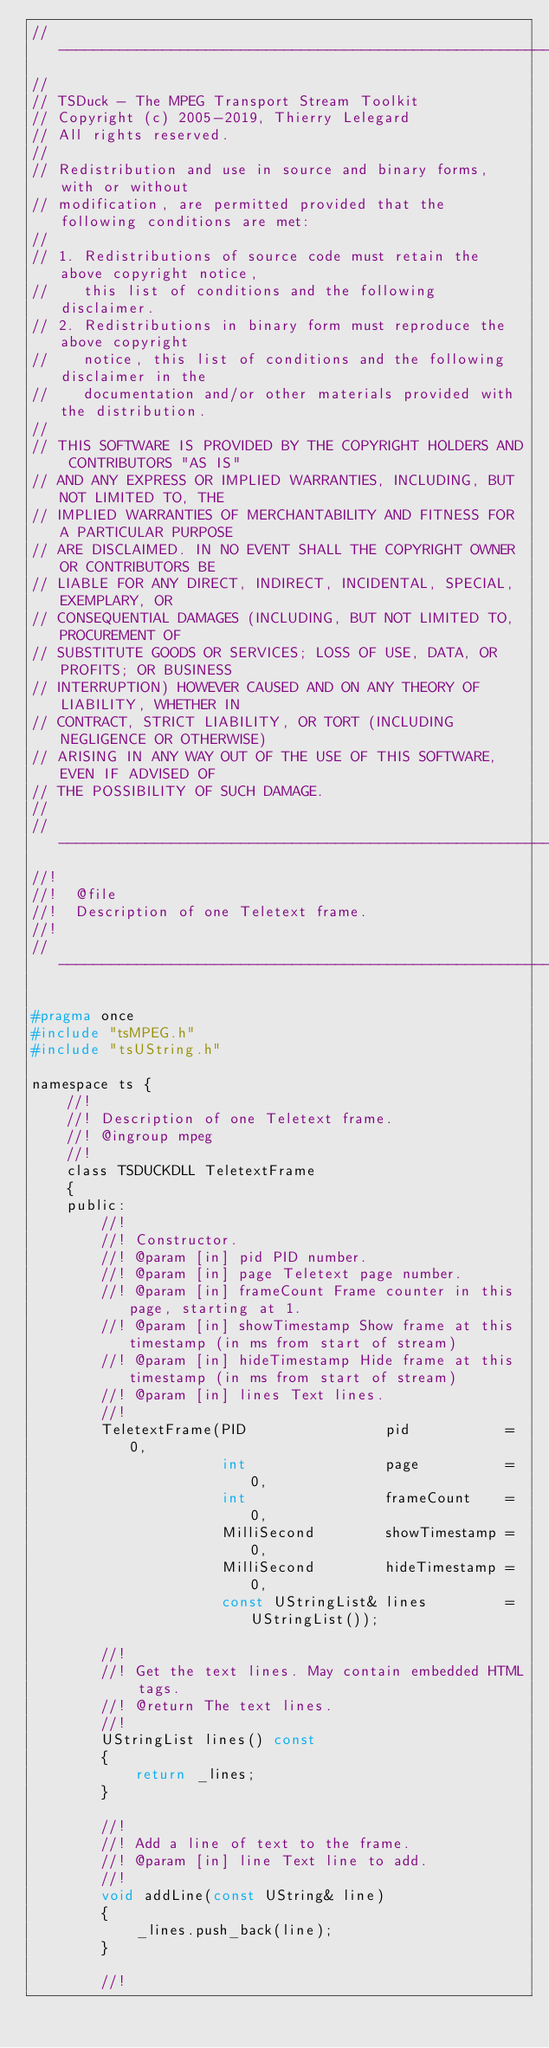<code> <loc_0><loc_0><loc_500><loc_500><_C_>//----------------------------------------------------------------------------
//
// TSDuck - The MPEG Transport Stream Toolkit
// Copyright (c) 2005-2019, Thierry Lelegard
// All rights reserved.
//
// Redistribution and use in source and binary forms, with or without
// modification, are permitted provided that the following conditions are met:
//
// 1. Redistributions of source code must retain the above copyright notice,
//    this list of conditions and the following disclaimer.
// 2. Redistributions in binary form must reproduce the above copyright
//    notice, this list of conditions and the following disclaimer in the
//    documentation and/or other materials provided with the distribution.
//
// THIS SOFTWARE IS PROVIDED BY THE COPYRIGHT HOLDERS AND CONTRIBUTORS "AS IS"
// AND ANY EXPRESS OR IMPLIED WARRANTIES, INCLUDING, BUT NOT LIMITED TO, THE
// IMPLIED WARRANTIES OF MERCHANTABILITY AND FITNESS FOR A PARTICULAR PURPOSE
// ARE DISCLAIMED. IN NO EVENT SHALL THE COPYRIGHT OWNER OR CONTRIBUTORS BE
// LIABLE FOR ANY DIRECT, INDIRECT, INCIDENTAL, SPECIAL, EXEMPLARY, OR
// CONSEQUENTIAL DAMAGES (INCLUDING, BUT NOT LIMITED TO, PROCUREMENT OF
// SUBSTITUTE GOODS OR SERVICES; LOSS OF USE, DATA, OR PROFITS; OR BUSINESS
// INTERRUPTION) HOWEVER CAUSED AND ON ANY THEORY OF LIABILITY, WHETHER IN
// CONTRACT, STRICT LIABILITY, OR TORT (INCLUDING NEGLIGENCE OR OTHERWISE)
// ARISING IN ANY WAY OUT OF THE USE OF THIS SOFTWARE, EVEN IF ADVISED OF
// THE POSSIBILITY OF SUCH DAMAGE.
//
//----------------------------------------------------------------------------
//!
//!  @file
//!  Description of one Teletext frame.
//!
//----------------------------------------------------------------------------

#pragma once
#include "tsMPEG.h"
#include "tsUString.h"

namespace ts {
    //!
    //! Description of one Teletext frame.
    //! @ingroup mpeg
    //!
    class TSDUCKDLL TeletextFrame
    {
    public:
        //!
        //! Constructor.
        //! @param [in] pid PID number.
        //! @param [in] page Teletext page number.
        //! @param [in] frameCount Frame counter in this page, starting at 1.
        //! @param [in] showTimestamp Show frame at this timestamp (in ms from start of stream)
        //! @param [in] hideTimestamp Hide frame at this timestamp (in ms from start of stream)
        //! @param [in] lines Text lines.
        //!
        TeletextFrame(PID                pid           = 0,
                      int                page          = 0,
                      int                frameCount    = 0,
                      MilliSecond        showTimestamp = 0,
                      MilliSecond        hideTimestamp = 0,
                      const UStringList& lines         = UStringList());

        //!
        //! Get the text lines. May contain embedded HTML tags.
        //! @return The text lines.
        //!
        UStringList lines() const
        {
            return _lines;
        }

        //!
        //! Add a line of text to the frame.
        //! @param [in] line Text line to add.
        //!
        void addLine(const UString& line)
        {
            _lines.push_back(line);
        }

        //!</code> 